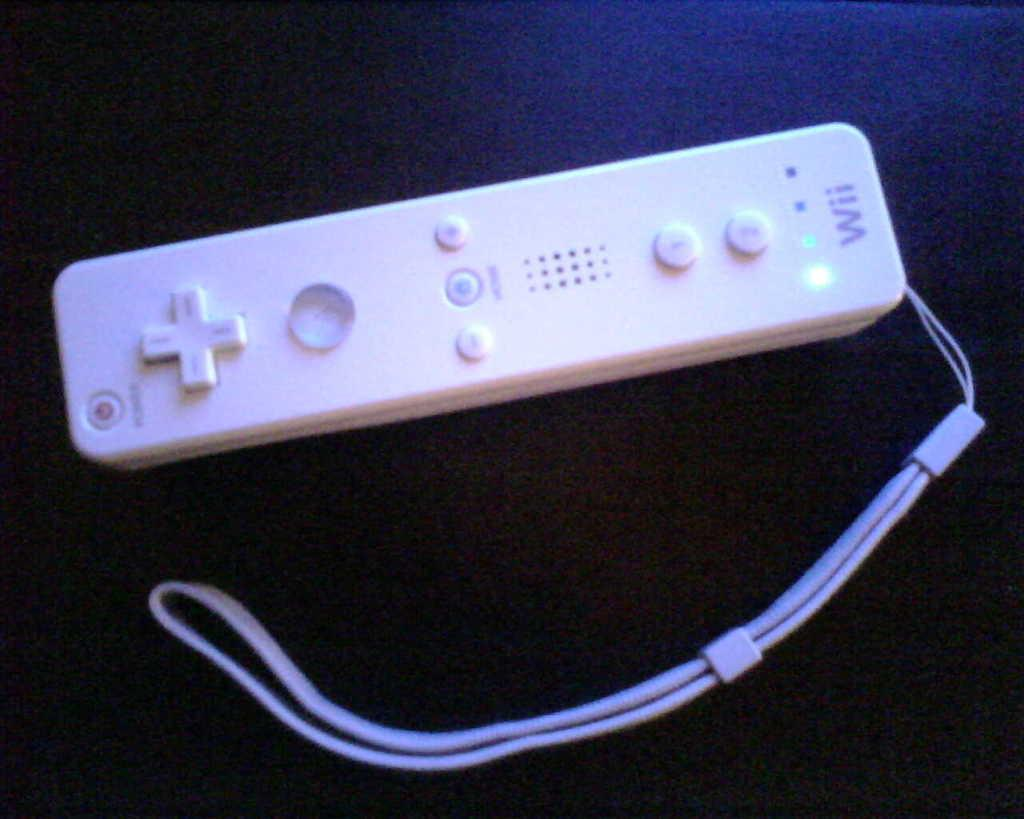<image>
Summarize the visual content of the image. A white remote that says wii is on a dark surface. 